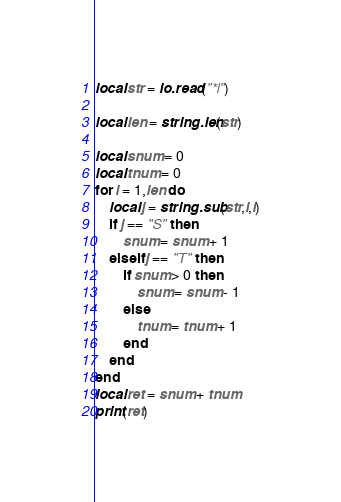<code> <loc_0><loc_0><loc_500><loc_500><_Lua_>local str = io.read("*l")

local len = string.len(str)

local snum = 0
local tnum = 0
for i = 1,len do
	local j = string.sub(str,i,i)
	if j == "S" then
		snum = snum + 1
	elseif j == "T" then
		if snum > 0 then
			snum = snum - 1
		else
			tnum = tnum + 1
		end
	end
end
local ret = snum + tnum
print(ret)</code> 